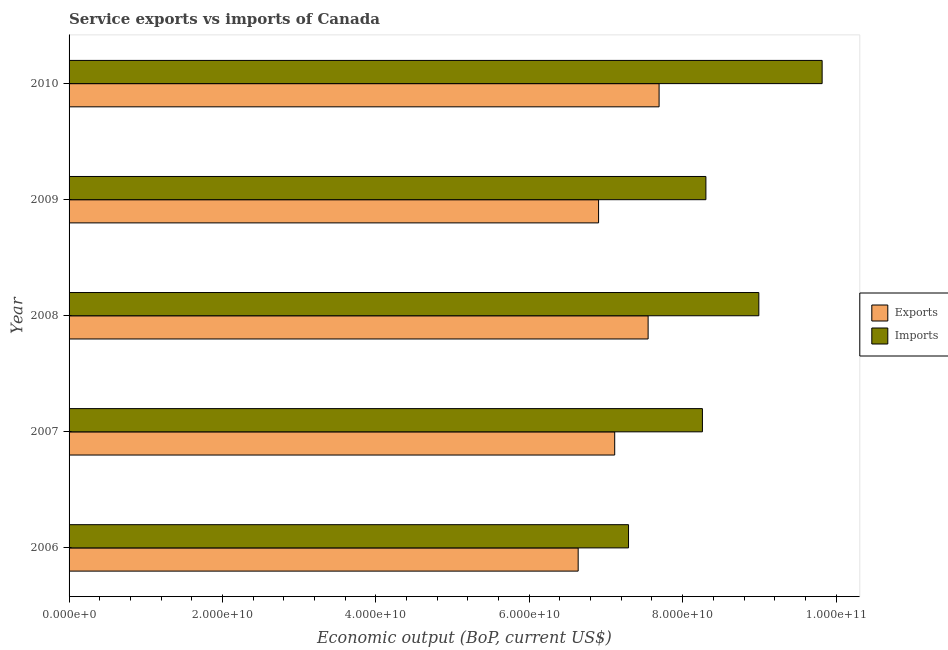How many groups of bars are there?
Offer a terse response. 5. Are the number of bars per tick equal to the number of legend labels?
Your response must be concise. Yes. Are the number of bars on each tick of the Y-axis equal?
Provide a succinct answer. Yes. How many bars are there on the 1st tick from the top?
Your response must be concise. 2. What is the label of the 2nd group of bars from the top?
Provide a short and direct response. 2009. What is the amount of service exports in 2007?
Your answer should be compact. 7.11e+1. Across all years, what is the maximum amount of service exports?
Make the answer very short. 7.69e+1. Across all years, what is the minimum amount of service exports?
Make the answer very short. 6.64e+1. What is the total amount of service exports in the graph?
Provide a short and direct response. 3.59e+11. What is the difference between the amount of service imports in 2006 and that in 2009?
Provide a succinct answer. -1.01e+1. What is the difference between the amount of service imports in 2009 and the amount of service exports in 2010?
Give a very brief answer. 6.10e+09. What is the average amount of service imports per year?
Keep it short and to the point. 8.53e+1. In the year 2008, what is the difference between the amount of service exports and amount of service imports?
Your answer should be very brief. -1.44e+1. What is the ratio of the amount of service exports in 2008 to that in 2010?
Your answer should be very brief. 0.98. Is the difference between the amount of service imports in 2006 and 2009 greater than the difference between the amount of service exports in 2006 and 2009?
Provide a short and direct response. No. What is the difference between the highest and the second highest amount of service exports?
Provide a succinct answer. 1.43e+09. What is the difference between the highest and the lowest amount of service exports?
Offer a terse response. 1.05e+1. Is the sum of the amount of service exports in 2006 and 2008 greater than the maximum amount of service imports across all years?
Make the answer very short. Yes. What does the 2nd bar from the top in 2009 represents?
Your answer should be compact. Exports. What does the 1st bar from the bottom in 2006 represents?
Offer a terse response. Exports. Where does the legend appear in the graph?
Provide a succinct answer. Center right. How many legend labels are there?
Keep it short and to the point. 2. What is the title of the graph?
Your response must be concise. Service exports vs imports of Canada. Does "IMF nonconcessional" appear as one of the legend labels in the graph?
Ensure brevity in your answer.  No. What is the label or title of the X-axis?
Keep it short and to the point. Economic output (BoP, current US$). What is the Economic output (BoP, current US$) of Exports in 2006?
Provide a succinct answer. 6.64e+1. What is the Economic output (BoP, current US$) in Imports in 2006?
Make the answer very short. 7.29e+1. What is the Economic output (BoP, current US$) in Exports in 2007?
Provide a short and direct response. 7.11e+1. What is the Economic output (BoP, current US$) of Imports in 2007?
Give a very brief answer. 8.26e+1. What is the Economic output (BoP, current US$) in Exports in 2008?
Provide a short and direct response. 7.55e+1. What is the Economic output (BoP, current US$) in Imports in 2008?
Make the answer very short. 8.99e+1. What is the Economic output (BoP, current US$) of Exports in 2009?
Provide a short and direct response. 6.90e+1. What is the Economic output (BoP, current US$) in Imports in 2009?
Offer a terse response. 8.30e+1. What is the Economic output (BoP, current US$) in Exports in 2010?
Your response must be concise. 7.69e+1. What is the Economic output (BoP, current US$) in Imports in 2010?
Your response must be concise. 9.82e+1. Across all years, what is the maximum Economic output (BoP, current US$) of Exports?
Provide a short and direct response. 7.69e+1. Across all years, what is the maximum Economic output (BoP, current US$) in Imports?
Make the answer very short. 9.82e+1. Across all years, what is the minimum Economic output (BoP, current US$) in Exports?
Ensure brevity in your answer.  6.64e+1. Across all years, what is the minimum Economic output (BoP, current US$) of Imports?
Keep it short and to the point. 7.29e+1. What is the total Economic output (BoP, current US$) of Exports in the graph?
Give a very brief answer. 3.59e+11. What is the total Economic output (BoP, current US$) of Imports in the graph?
Your response must be concise. 4.27e+11. What is the difference between the Economic output (BoP, current US$) in Exports in 2006 and that in 2007?
Your answer should be compact. -4.76e+09. What is the difference between the Economic output (BoP, current US$) of Imports in 2006 and that in 2007?
Ensure brevity in your answer.  -9.63e+09. What is the difference between the Economic output (BoP, current US$) of Exports in 2006 and that in 2008?
Offer a very short reply. -9.12e+09. What is the difference between the Economic output (BoP, current US$) in Imports in 2006 and that in 2008?
Keep it short and to the point. -1.70e+1. What is the difference between the Economic output (BoP, current US$) in Exports in 2006 and that in 2009?
Your answer should be very brief. -2.66e+09. What is the difference between the Economic output (BoP, current US$) of Imports in 2006 and that in 2009?
Give a very brief answer. -1.01e+1. What is the difference between the Economic output (BoP, current US$) in Exports in 2006 and that in 2010?
Your response must be concise. -1.05e+1. What is the difference between the Economic output (BoP, current US$) in Imports in 2006 and that in 2010?
Your answer should be compact. -2.52e+1. What is the difference between the Economic output (BoP, current US$) of Exports in 2007 and that in 2008?
Keep it short and to the point. -4.36e+09. What is the difference between the Economic output (BoP, current US$) of Imports in 2007 and that in 2008?
Give a very brief answer. -7.35e+09. What is the difference between the Economic output (BoP, current US$) in Exports in 2007 and that in 2009?
Your answer should be compact. 2.10e+09. What is the difference between the Economic output (BoP, current US$) in Imports in 2007 and that in 2009?
Provide a short and direct response. -4.55e+08. What is the difference between the Economic output (BoP, current US$) in Exports in 2007 and that in 2010?
Provide a short and direct response. -5.79e+09. What is the difference between the Economic output (BoP, current US$) of Imports in 2007 and that in 2010?
Provide a short and direct response. -1.56e+1. What is the difference between the Economic output (BoP, current US$) in Exports in 2008 and that in 2009?
Keep it short and to the point. 6.46e+09. What is the difference between the Economic output (BoP, current US$) of Imports in 2008 and that in 2009?
Make the answer very short. 6.90e+09. What is the difference between the Economic output (BoP, current US$) of Exports in 2008 and that in 2010?
Offer a terse response. -1.43e+09. What is the difference between the Economic output (BoP, current US$) in Imports in 2008 and that in 2010?
Provide a succinct answer. -8.25e+09. What is the difference between the Economic output (BoP, current US$) in Exports in 2009 and that in 2010?
Your response must be concise. -7.89e+09. What is the difference between the Economic output (BoP, current US$) in Imports in 2009 and that in 2010?
Provide a succinct answer. -1.52e+1. What is the difference between the Economic output (BoP, current US$) in Exports in 2006 and the Economic output (BoP, current US$) in Imports in 2007?
Your answer should be compact. -1.62e+1. What is the difference between the Economic output (BoP, current US$) in Exports in 2006 and the Economic output (BoP, current US$) in Imports in 2008?
Give a very brief answer. -2.36e+1. What is the difference between the Economic output (BoP, current US$) of Exports in 2006 and the Economic output (BoP, current US$) of Imports in 2009?
Your answer should be compact. -1.67e+1. What is the difference between the Economic output (BoP, current US$) of Exports in 2006 and the Economic output (BoP, current US$) of Imports in 2010?
Provide a short and direct response. -3.18e+1. What is the difference between the Economic output (BoP, current US$) in Exports in 2007 and the Economic output (BoP, current US$) in Imports in 2008?
Your answer should be compact. -1.88e+1. What is the difference between the Economic output (BoP, current US$) of Exports in 2007 and the Economic output (BoP, current US$) of Imports in 2009?
Provide a short and direct response. -1.19e+1. What is the difference between the Economic output (BoP, current US$) in Exports in 2007 and the Economic output (BoP, current US$) in Imports in 2010?
Offer a terse response. -2.70e+1. What is the difference between the Economic output (BoP, current US$) in Exports in 2008 and the Economic output (BoP, current US$) in Imports in 2009?
Your answer should be compact. -7.53e+09. What is the difference between the Economic output (BoP, current US$) of Exports in 2008 and the Economic output (BoP, current US$) of Imports in 2010?
Your answer should be compact. -2.27e+1. What is the difference between the Economic output (BoP, current US$) in Exports in 2009 and the Economic output (BoP, current US$) in Imports in 2010?
Provide a short and direct response. -2.91e+1. What is the average Economic output (BoP, current US$) of Exports per year?
Provide a succinct answer. 7.18e+1. What is the average Economic output (BoP, current US$) in Imports per year?
Your response must be concise. 8.53e+1. In the year 2006, what is the difference between the Economic output (BoP, current US$) of Exports and Economic output (BoP, current US$) of Imports?
Offer a terse response. -6.57e+09. In the year 2007, what is the difference between the Economic output (BoP, current US$) of Exports and Economic output (BoP, current US$) of Imports?
Offer a very short reply. -1.14e+1. In the year 2008, what is the difference between the Economic output (BoP, current US$) in Exports and Economic output (BoP, current US$) in Imports?
Ensure brevity in your answer.  -1.44e+1. In the year 2009, what is the difference between the Economic output (BoP, current US$) of Exports and Economic output (BoP, current US$) of Imports?
Make the answer very short. -1.40e+1. In the year 2010, what is the difference between the Economic output (BoP, current US$) in Exports and Economic output (BoP, current US$) in Imports?
Keep it short and to the point. -2.13e+1. What is the ratio of the Economic output (BoP, current US$) of Exports in 2006 to that in 2007?
Provide a succinct answer. 0.93. What is the ratio of the Economic output (BoP, current US$) of Imports in 2006 to that in 2007?
Give a very brief answer. 0.88. What is the ratio of the Economic output (BoP, current US$) of Exports in 2006 to that in 2008?
Give a very brief answer. 0.88. What is the ratio of the Economic output (BoP, current US$) of Imports in 2006 to that in 2008?
Make the answer very short. 0.81. What is the ratio of the Economic output (BoP, current US$) in Exports in 2006 to that in 2009?
Keep it short and to the point. 0.96. What is the ratio of the Economic output (BoP, current US$) in Imports in 2006 to that in 2009?
Provide a succinct answer. 0.88. What is the ratio of the Economic output (BoP, current US$) in Exports in 2006 to that in 2010?
Your answer should be very brief. 0.86. What is the ratio of the Economic output (BoP, current US$) of Imports in 2006 to that in 2010?
Your answer should be very brief. 0.74. What is the ratio of the Economic output (BoP, current US$) in Exports in 2007 to that in 2008?
Offer a very short reply. 0.94. What is the ratio of the Economic output (BoP, current US$) of Imports in 2007 to that in 2008?
Make the answer very short. 0.92. What is the ratio of the Economic output (BoP, current US$) in Exports in 2007 to that in 2009?
Ensure brevity in your answer.  1.03. What is the ratio of the Economic output (BoP, current US$) of Exports in 2007 to that in 2010?
Ensure brevity in your answer.  0.92. What is the ratio of the Economic output (BoP, current US$) of Imports in 2007 to that in 2010?
Keep it short and to the point. 0.84. What is the ratio of the Economic output (BoP, current US$) of Exports in 2008 to that in 2009?
Give a very brief answer. 1.09. What is the ratio of the Economic output (BoP, current US$) of Imports in 2008 to that in 2009?
Make the answer very short. 1.08. What is the ratio of the Economic output (BoP, current US$) in Exports in 2008 to that in 2010?
Your answer should be compact. 0.98. What is the ratio of the Economic output (BoP, current US$) in Imports in 2008 to that in 2010?
Keep it short and to the point. 0.92. What is the ratio of the Economic output (BoP, current US$) in Exports in 2009 to that in 2010?
Provide a succinct answer. 0.9. What is the ratio of the Economic output (BoP, current US$) in Imports in 2009 to that in 2010?
Offer a terse response. 0.85. What is the difference between the highest and the second highest Economic output (BoP, current US$) in Exports?
Ensure brevity in your answer.  1.43e+09. What is the difference between the highest and the second highest Economic output (BoP, current US$) in Imports?
Make the answer very short. 8.25e+09. What is the difference between the highest and the lowest Economic output (BoP, current US$) of Exports?
Provide a succinct answer. 1.05e+1. What is the difference between the highest and the lowest Economic output (BoP, current US$) of Imports?
Your response must be concise. 2.52e+1. 